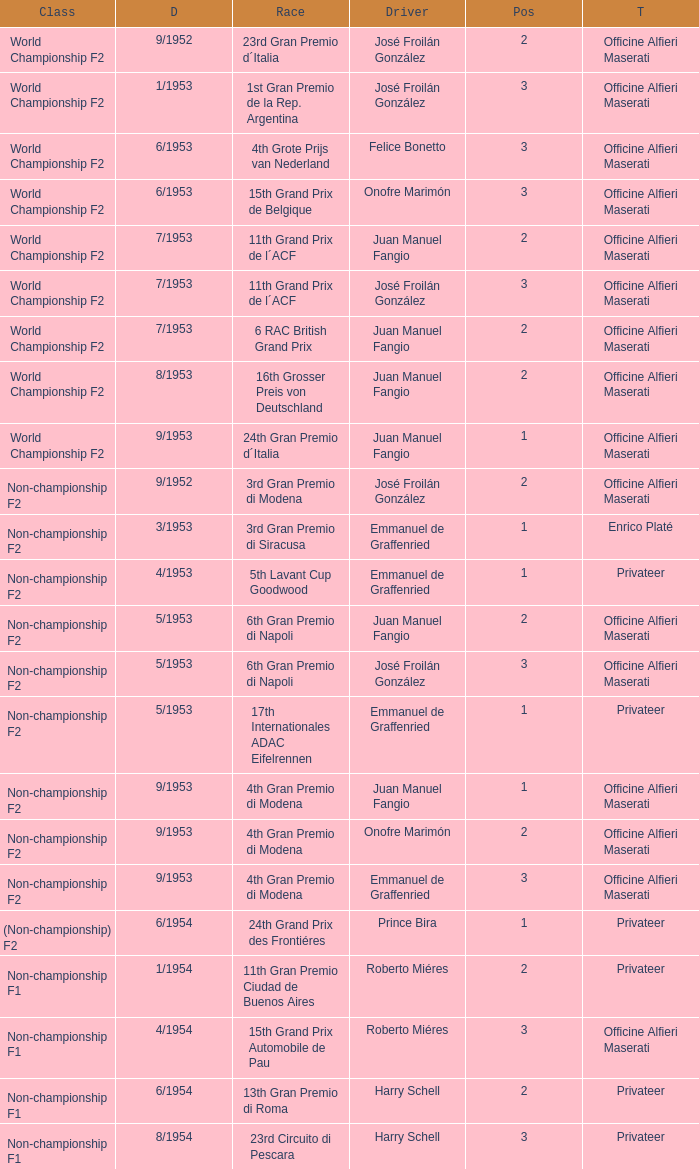What class has the date of 8/1954? Non-championship F1. 